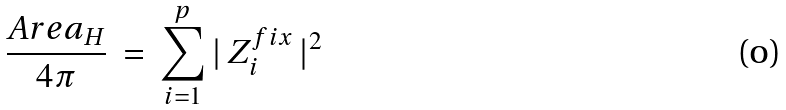Convert formula to latex. <formula><loc_0><loc_0><loc_500><loc_500>\frac { A r e a _ { H } } { 4 \pi } \, = \, \sum _ { i = 1 } ^ { p } | \, Z _ { i } ^ { f i x } \, | ^ { 2 }</formula> 